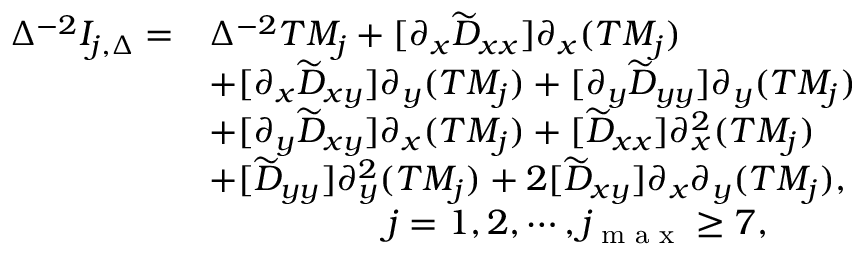<formula> <loc_0><loc_0><loc_500><loc_500>\begin{array} { r l } { \Delta ^ { - 2 } I _ { j , \Delta } = } & { \Delta ^ { - 2 } T M _ { j } + [ \partial _ { x } \widetilde { D } _ { x x } ] \partial _ { x } ( T M _ { j } ) } \\ & { + [ \partial _ { x } \widetilde { D } _ { x y } ] \partial _ { y } ( T M _ { j } ) + [ \partial _ { y } \widetilde { D } _ { y y } ] \partial _ { y } ( T M _ { j } ) } \\ & { + [ \partial _ { y } \widetilde { D } _ { x y } ] \partial _ { x } ( T M _ { j } ) + [ \widetilde { D } _ { x x } ] \partial _ { x } ^ { 2 } ( T M _ { j } ) } \\ & { + [ \widetilde { D } _ { y y } ] \partial _ { y } ^ { 2 } ( T M _ { j } ) + 2 [ \widetilde { D } _ { x y } ] \partial _ { x } \partial _ { y } ( T M _ { j } ) , } \\ & { \quad j = 1 , 2 , \cdots , j _ { \max } \geq 7 , } \end{array}</formula> 